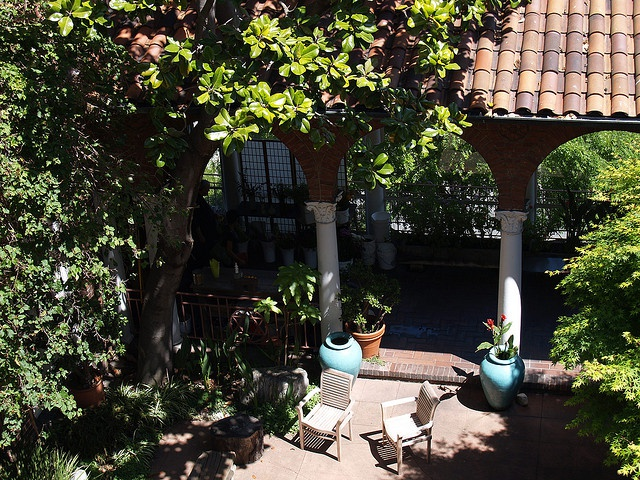Describe the objects in this image and their specific colors. I can see potted plant in khaki, black, gray, darkgreen, and darkgray tones, potted plant in khaki, black, gray, maroon, and darkgreen tones, potted plant in khaki, black, gray, darkgreen, and darkgray tones, potted plant in khaki, black, gray, darkgreen, and olive tones, and potted plant in khaki, black, gray, tan, and maroon tones in this image. 